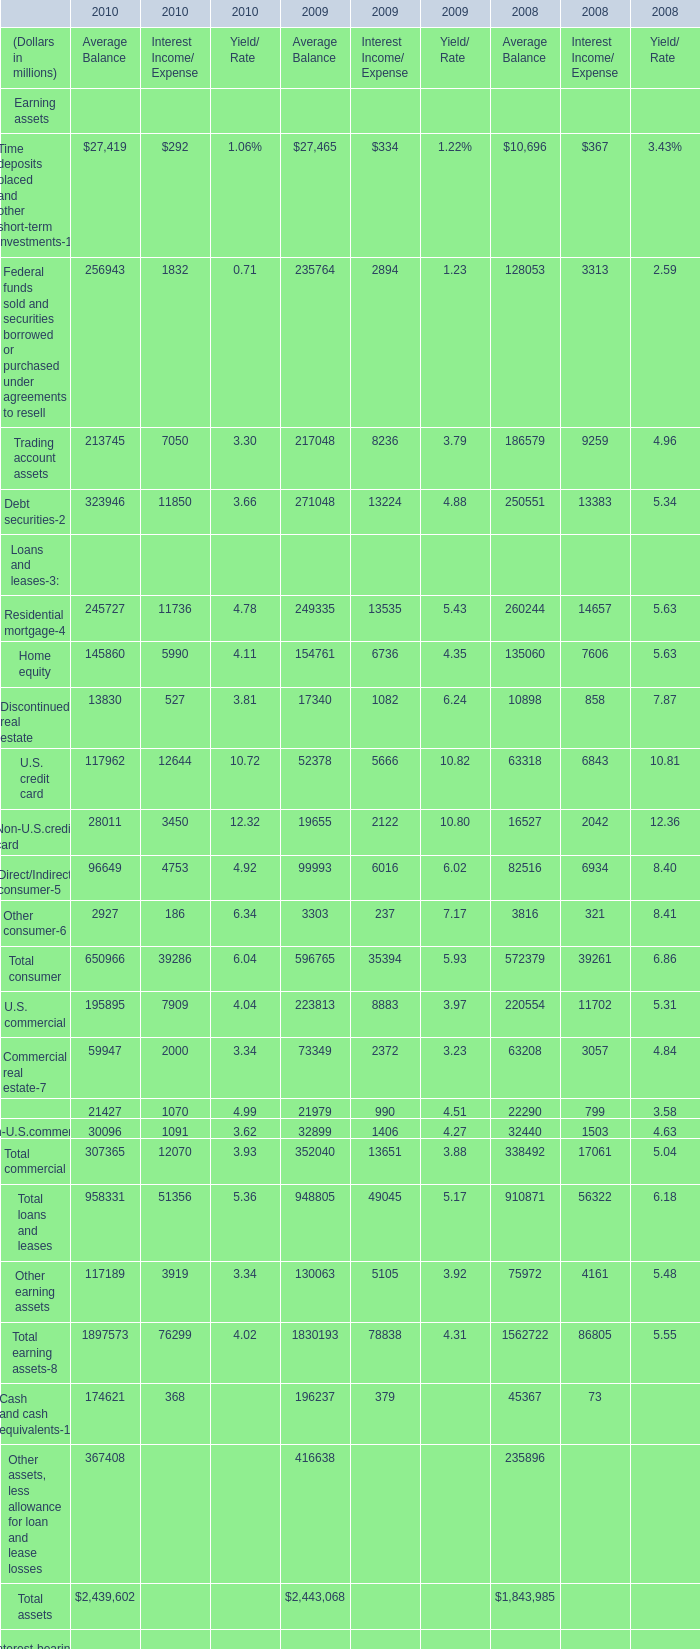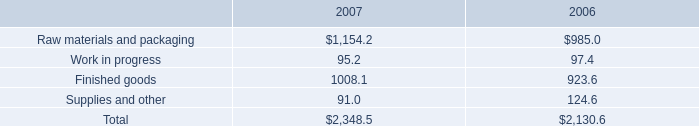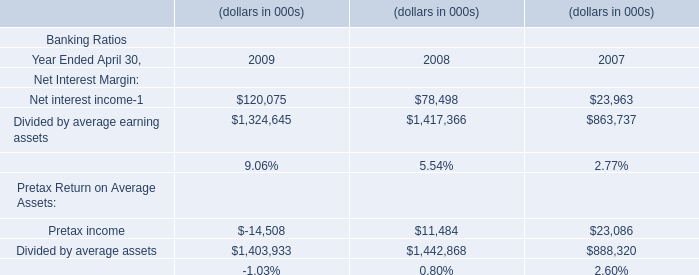What is the average amount of Raw materials and packaging of 2007, and U.S. commercial of 2009 Average Balance ? 
Computations: ((1154.2 + 223813.0) / 2)
Answer: 112483.6. 